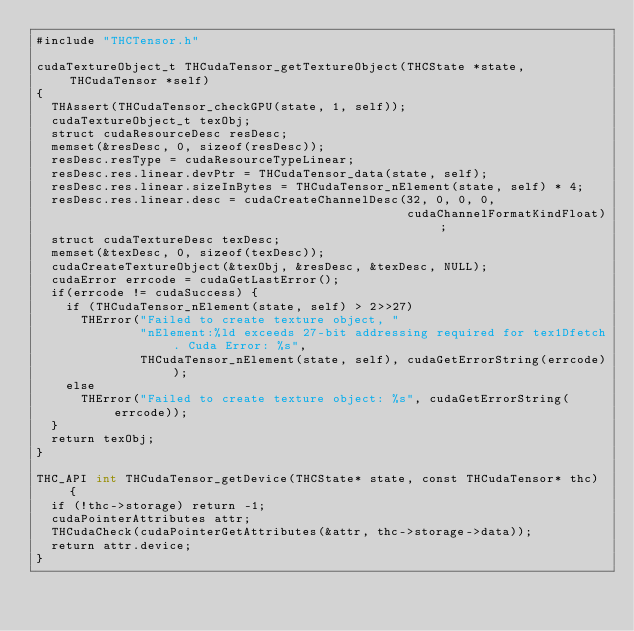<code> <loc_0><loc_0><loc_500><loc_500><_Cuda_>#include "THCTensor.h"

cudaTextureObject_t THCudaTensor_getTextureObject(THCState *state, THCudaTensor *self)
{
  THAssert(THCudaTensor_checkGPU(state, 1, self));
  cudaTextureObject_t texObj;
  struct cudaResourceDesc resDesc;
  memset(&resDesc, 0, sizeof(resDesc));
  resDesc.resType = cudaResourceTypeLinear;
  resDesc.res.linear.devPtr = THCudaTensor_data(state, self);
  resDesc.res.linear.sizeInBytes = THCudaTensor_nElement(state, self) * 4;
  resDesc.res.linear.desc = cudaCreateChannelDesc(32, 0, 0, 0,
                                                  cudaChannelFormatKindFloat);
  struct cudaTextureDesc texDesc;
  memset(&texDesc, 0, sizeof(texDesc));
  cudaCreateTextureObject(&texObj, &resDesc, &texDesc, NULL);
  cudaError errcode = cudaGetLastError();
  if(errcode != cudaSuccess) {
    if (THCudaTensor_nElement(state, self) > 2>>27)
      THError("Failed to create texture object, "
              "nElement:%ld exceeds 27-bit addressing required for tex1Dfetch. Cuda Error: %s",
              THCudaTensor_nElement(state, self), cudaGetErrorString(errcode));
    else
      THError("Failed to create texture object: %s", cudaGetErrorString(errcode));
  }
  return texObj;
}

THC_API int THCudaTensor_getDevice(THCState* state, const THCudaTensor* thc) {
  if (!thc->storage) return -1;
  cudaPointerAttributes attr;
  THCudaCheck(cudaPointerGetAttributes(&attr, thc->storage->data));
  return attr.device;
}
</code> 